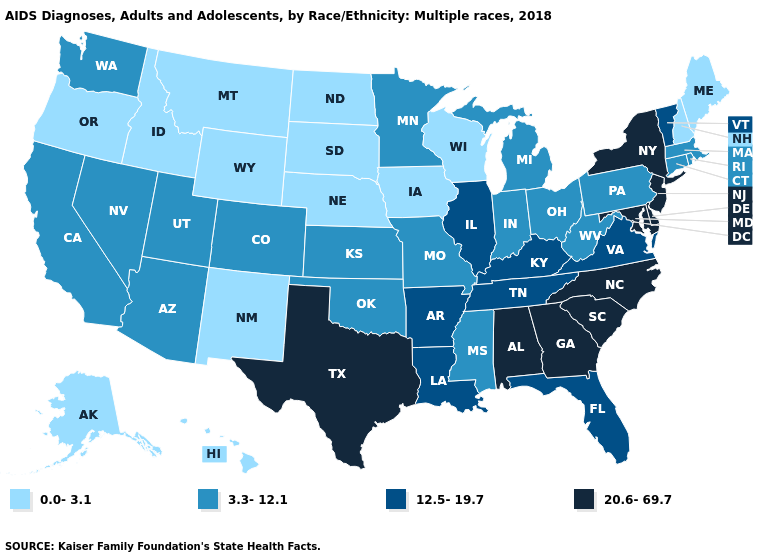Which states have the highest value in the USA?
Write a very short answer. Alabama, Delaware, Georgia, Maryland, New Jersey, New York, North Carolina, South Carolina, Texas. Which states have the highest value in the USA?
Give a very brief answer. Alabama, Delaware, Georgia, Maryland, New Jersey, New York, North Carolina, South Carolina, Texas. What is the highest value in states that border Arizona?
Write a very short answer. 3.3-12.1. What is the value of Alabama?
Short answer required. 20.6-69.7. Does Indiana have a lower value than Utah?
Short answer required. No. Does the map have missing data?
Be succinct. No. What is the value of Alabama?
Be succinct. 20.6-69.7. How many symbols are there in the legend?
Write a very short answer. 4. Which states have the highest value in the USA?
Answer briefly. Alabama, Delaware, Georgia, Maryland, New Jersey, New York, North Carolina, South Carolina, Texas. Does Alabama have the highest value in the USA?
Keep it brief. Yes. What is the value of South Dakota?
Give a very brief answer. 0.0-3.1. Name the states that have a value in the range 0.0-3.1?
Quick response, please. Alaska, Hawaii, Idaho, Iowa, Maine, Montana, Nebraska, New Hampshire, New Mexico, North Dakota, Oregon, South Dakota, Wisconsin, Wyoming. Name the states that have a value in the range 0.0-3.1?
Quick response, please. Alaska, Hawaii, Idaho, Iowa, Maine, Montana, Nebraska, New Hampshire, New Mexico, North Dakota, Oregon, South Dakota, Wisconsin, Wyoming. Name the states that have a value in the range 3.3-12.1?
Give a very brief answer. Arizona, California, Colorado, Connecticut, Indiana, Kansas, Massachusetts, Michigan, Minnesota, Mississippi, Missouri, Nevada, Ohio, Oklahoma, Pennsylvania, Rhode Island, Utah, Washington, West Virginia. Which states hav the highest value in the South?
Be succinct. Alabama, Delaware, Georgia, Maryland, North Carolina, South Carolina, Texas. 